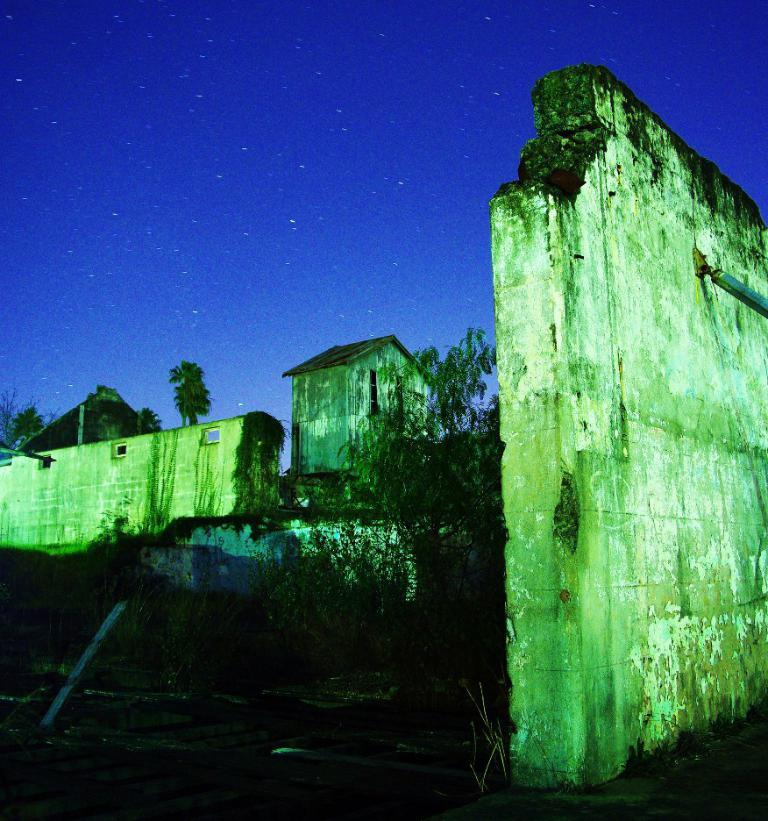What type of structures can be seen in the image? There are walls and a small shed in the image. What natural elements are present in the image? There are trees and stars visible in the image. What else can be found in the image besides the walls, trees, and shed? There are objects in the image. What type of education does the brother receive in the image? There is no brother present in the image, so it is not possible to answer that question. 